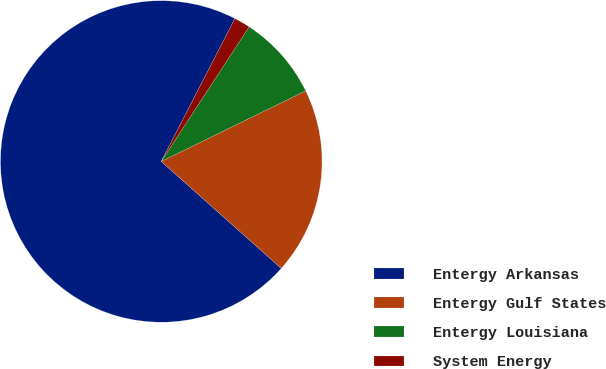Convert chart. <chart><loc_0><loc_0><loc_500><loc_500><pie_chart><fcel>Entergy Arkansas<fcel>Entergy Gulf States<fcel>Entergy Louisiana<fcel>System Energy<nl><fcel>70.99%<fcel>18.82%<fcel>8.56%<fcel>1.63%<nl></chart> 